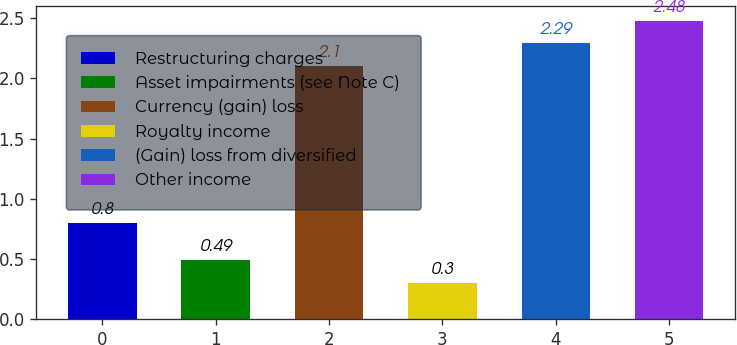Convert chart. <chart><loc_0><loc_0><loc_500><loc_500><bar_chart><fcel>Restructuring charges<fcel>Asset impairments (see Note C)<fcel>Currency (gain) loss<fcel>Royalty income<fcel>(Gain) loss from diversified<fcel>Other income<nl><fcel>0.8<fcel>0.49<fcel>2.1<fcel>0.3<fcel>2.29<fcel>2.48<nl></chart> 